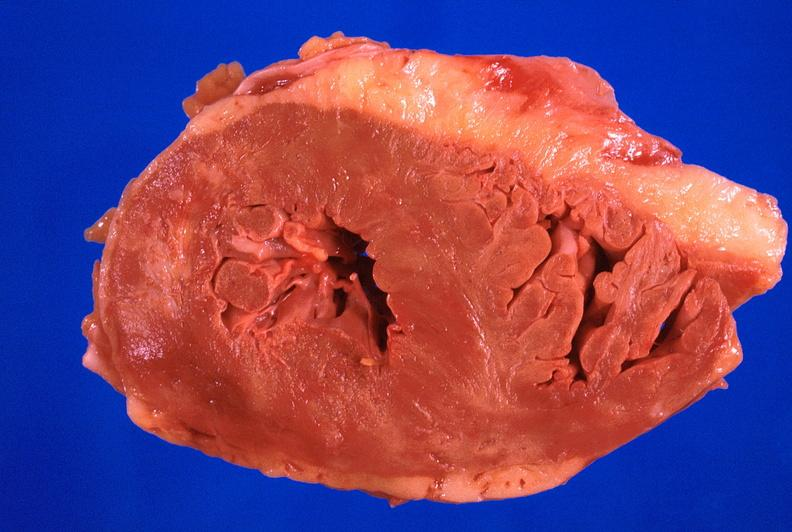s cardiovascular present?
Answer the question using a single word or phrase. Yes 